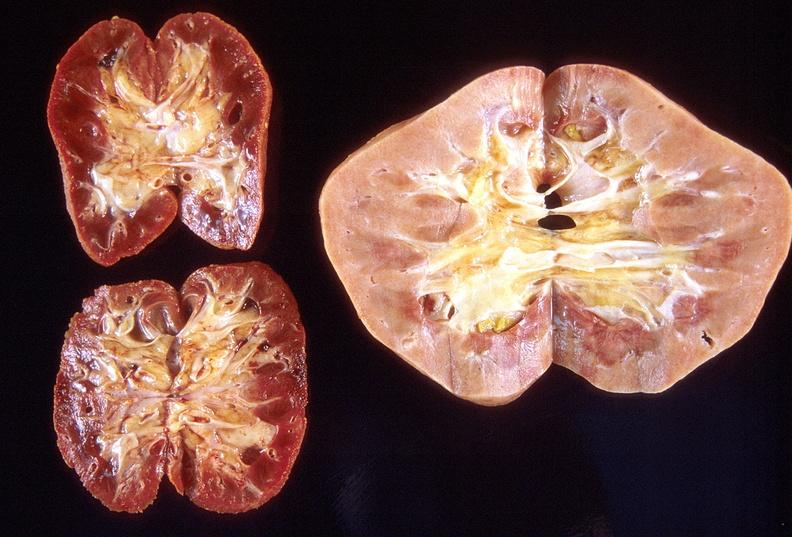where is this?
Answer the question using a single word or phrase. Urinary 